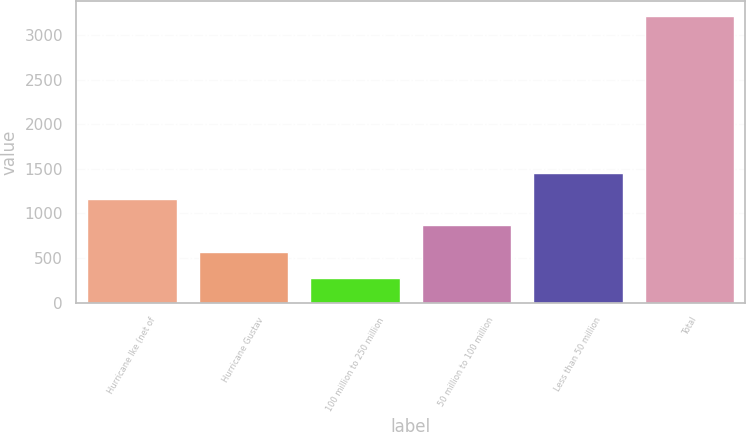Convert chart. <chart><loc_0><loc_0><loc_500><loc_500><bar_chart><fcel>Hurricane Ike (net of<fcel>Hurricane Gustav<fcel>100 million to 250 million<fcel>50 million to 100 million<fcel>Less than 50 million<fcel>Total<nl><fcel>1159.7<fcel>571.9<fcel>278<fcel>865.8<fcel>1453.6<fcel>3217<nl></chart> 